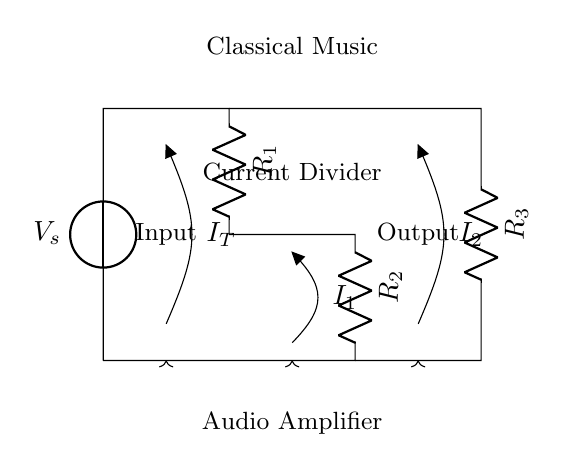what is the source voltage of this circuit? The source voltage \( V_s \) is indicated by the voltage source in the diagram. It provides the input voltage for the entire circuit.
Answer: V_s what are the resistances present in the circuit? The circuit has three resistors: \( R_1 \), \( R_2 \), and \( R_3 \). Their placement and labels clearly indicate their presence.
Answer: R_1, R_2, R_3 what is the current flowing through \( R_1 \)? The current flowing through \( R_1 \) is designated as \( I_1 \) in the diagram. The arrow indicates the direction of current flow, specifically through this resistor.
Answer: I_1 what is the total current entering the circuit? The total current entering the circuit is represented as \( I_T \) in the diagram. It is the current that comes from the voltage source before division occurs.
Answer: I_T how are the currents divided in this circuit? The currents in a current divider circuit are divided inversely proportional to the resistances. The formula for the division is based on the resistances present, leading to specific values for \( I_1 \) and \( I_2 \).
Answer: Inversely proportional to resistances which component is primarily responsible for the current division effect? The current division effect in this circuit is primarily due to the arrangement of the resistors \( R_1 \), \( R_2 \), and \( R_3 \). Their configuration directly influences how the total current splits between them.
Answer: Resistors 